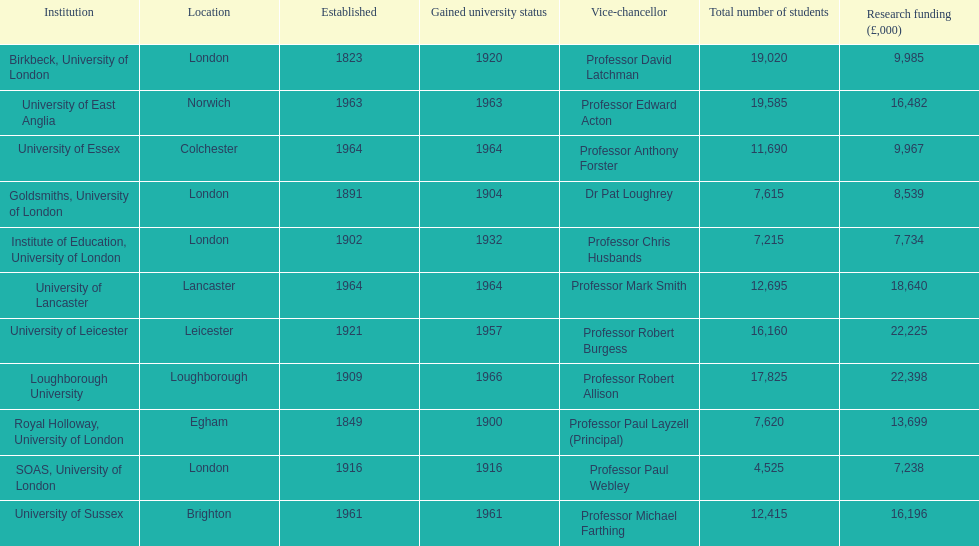Which organization receives the highest amount of funding for research? Loughborough University. 